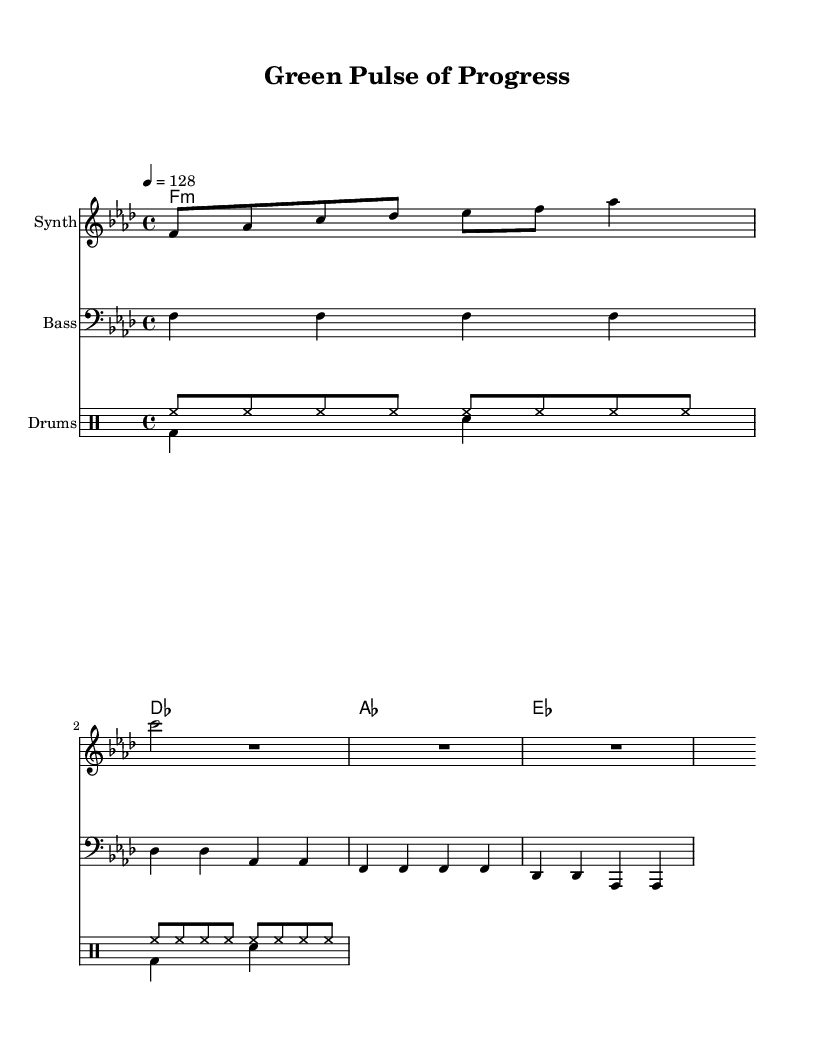What is the key signature of this music? The key signature is F minor, indicated by the presence of four flats (B♭, E♭, A♭, and D♭) in the key signature.
Answer: F minor What is the time signature of the piece? The time signature is found at the beginning of the sheet music and is notated as 4/4, meaning there are four beats in a measure, and the quarter note gets one beat.
Answer: 4/4 What is the tempo marking of the music? The tempo is indicated by the marking "4 = 128", which refers to the quarter note being played at a speed of 128 beats per minute, providing a steady and upbeat pace for the piece.
Answer: 128 How many measures are there in the melody? By counting the measures in the melody section, we see there are a total of five measures, including the rest measures.
Answer: 5 What instruments are present in the score? The score features a Synth for the melody, a Bass for the bass line, and a Drum Staff for percussion, which is typical of house music that utilizes various electronic instruments.
Answer: Synth, Bass, Drums What chord is played in the first measure? The first measure features the chord F minor (notated as f1:m), which consists of the notes F, A♭, and C, establishing the harmonic foundation of the piece right from the start.
Answer: F minor What style of music does this score represent? The score is categorized as Progressive House music due to its rhythmic drive and layered melodic lines, often associated with electronic dance music designed for community engagement and empowerment through sound.
Answer: Progressive House 